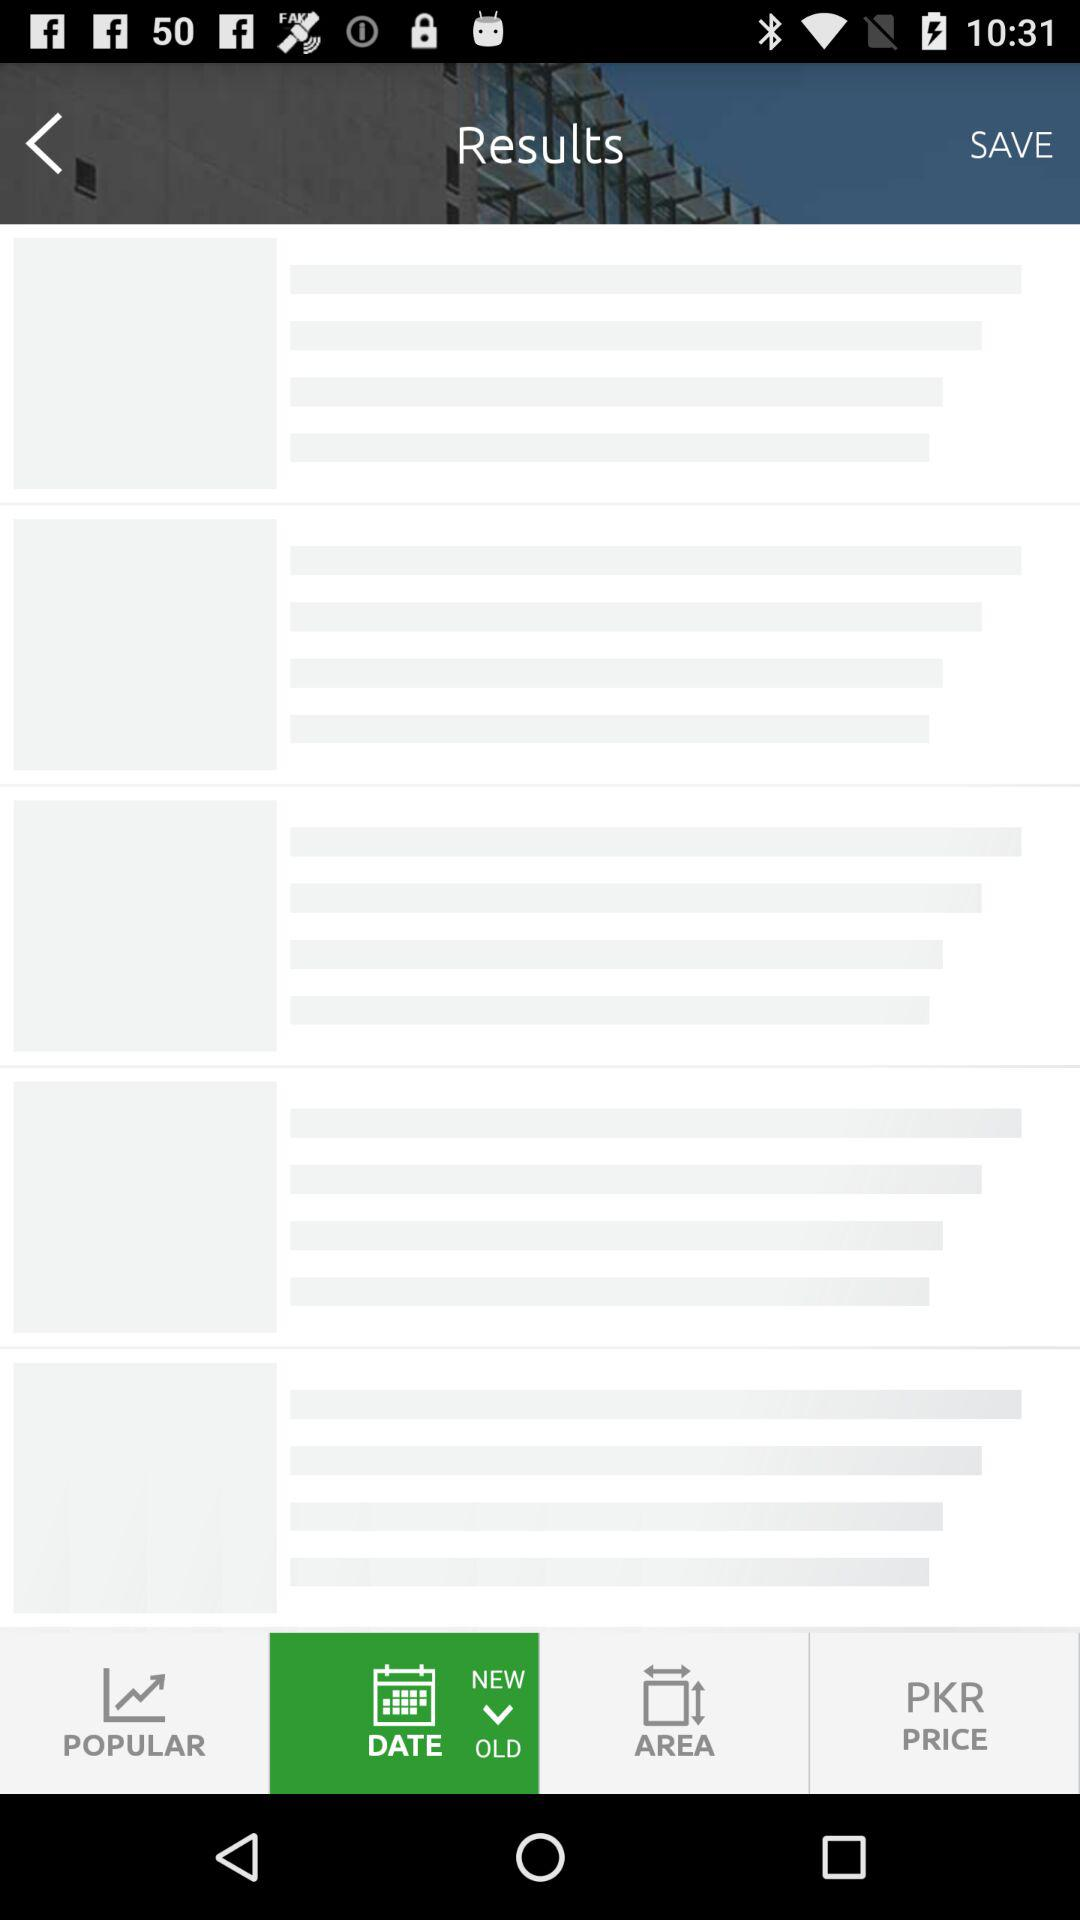How many bedrooms does the property have?
Answer the question using a single word or phrase. 5 